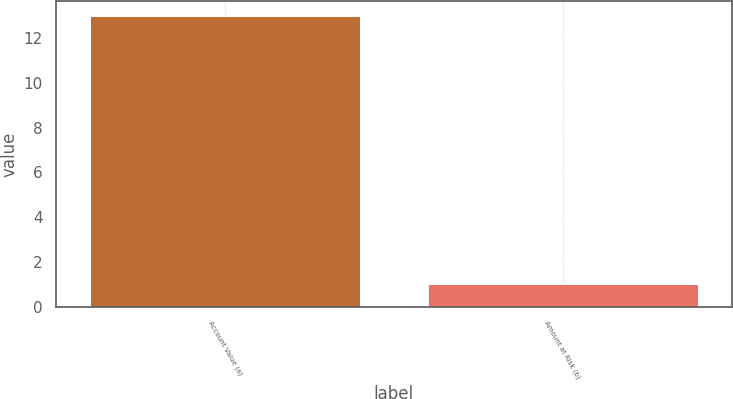Convert chart. <chart><loc_0><loc_0><loc_500><loc_500><bar_chart><fcel>Account Value (a)<fcel>Amount at Risk (b)<nl><fcel>13<fcel>1<nl></chart> 